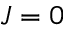<formula> <loc_0><loc_0><loc_500><loc_500>J = 0</formula> 